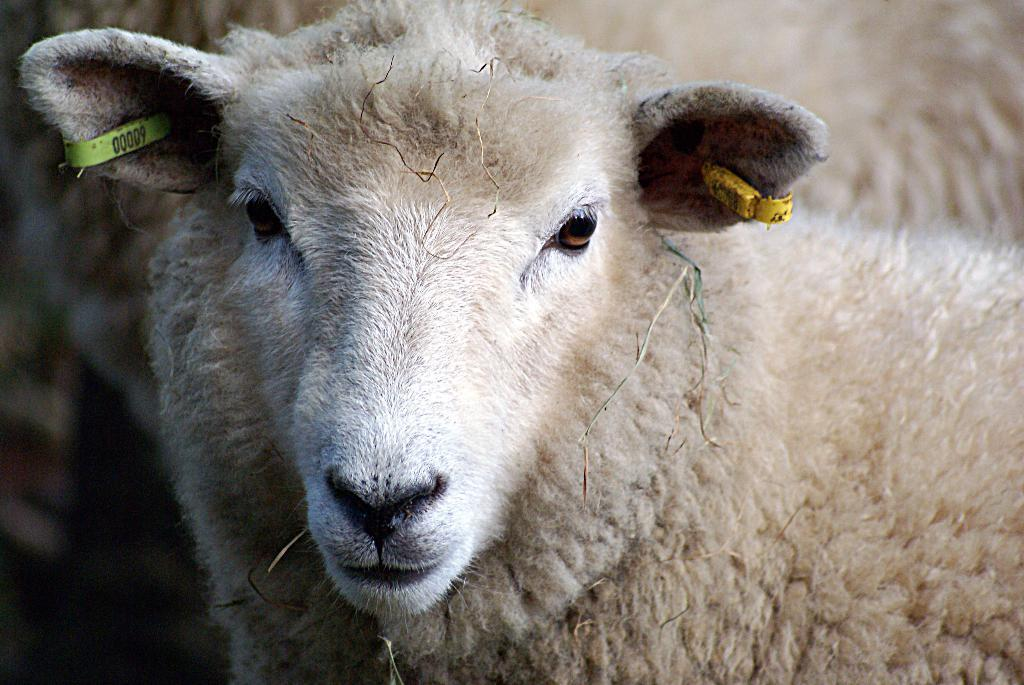What type of creature is present in the image? There is an animal in the image. Can you describe the background of the image? The background of the image is blurry. What type of meat is being served in the image? There is no reference to meat or any food in the image, so it's not possible to determine what, if any, meat might be served. 